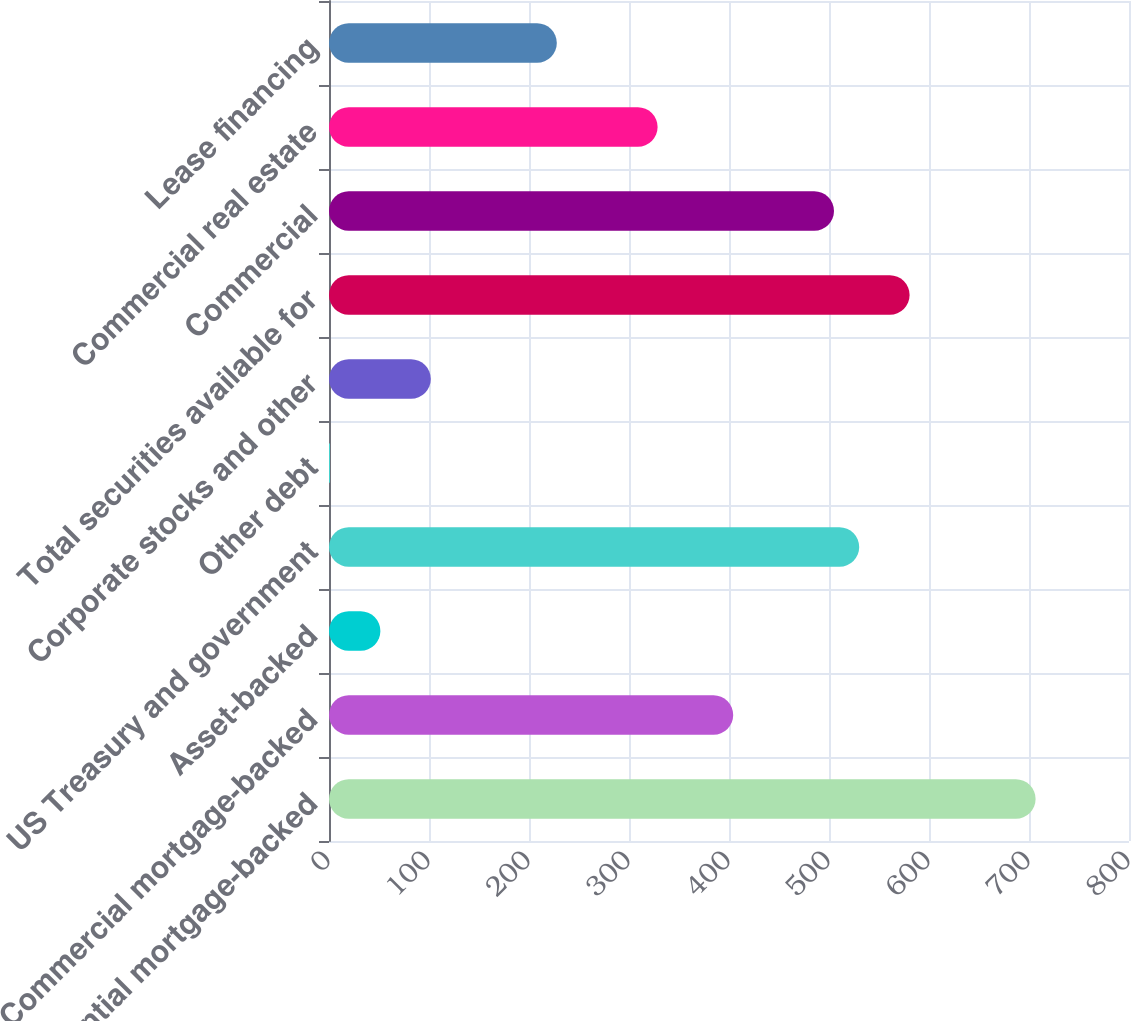Convert chart to OTSL. <chart><loc_0><loc_0><loc_500><loc_500><bar_chart><fcel>Residential mortgage-backed<fcel>Commercial mortgage-backed<fcel>Asset-backed<fcel>US Treasury and government<fcel>Other debt<fcel>Corporate stocks and other<fcel>Total securities available for<fcel>Commercial<fcel>Commercial real estate<fcel>Lease financing<nl><fcel>706.6<fcel>404.2<fcel>51.4<fcel>530.2<fcel>1<fcel>101.8<fcel>580.6<fcel>505<fcel>328.6<fcel>227.8<nl></chart> 